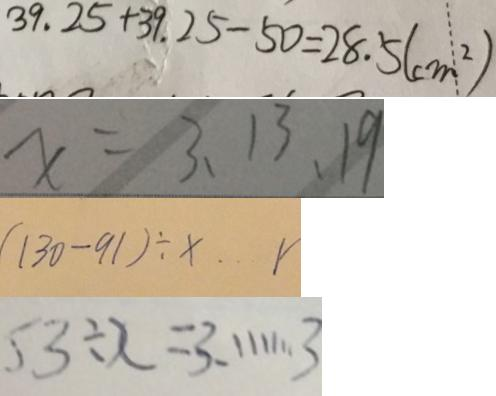Convert formula to latex. <formula><loc_0><loc_0><loc_500><loc_500>3 9 . 2 5 + 3 9 . 2 5 - 5 0 = 2 8 . 5 ( c m ^ { 2 } ) 
 x = 3 、 1 3 、 1 9 
 ( 1 3 0 - 9 1 ) \div x \cdots r 
 5 3 \div x = 3 . \cdots 3</formula> 